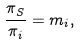<formula> <loc_0><loc_0><loc_500><loc_500>\frac { \pi _ { S } } { \pi _ { i } } = m _ { i } ,</formula> 